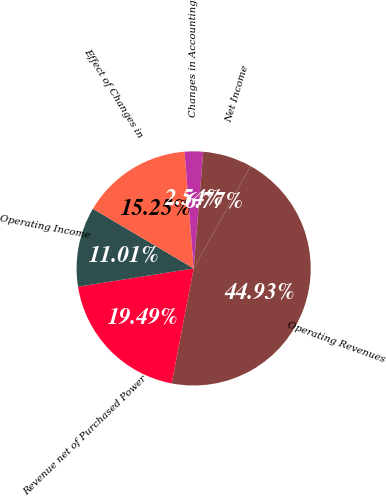Convert chart. <chart><loc_0><loc_0><loc_500><loc_500><pie_chart><fcel>Operating Revenues<fcel>Revenue net of Purchased Power<fcel>Operating Income<fcel>Effect of Changes in<fcel>Changes in Accounting<fcel>Net Income<nl><fcel>44.93%<fcel>19.49%<fcel>11.01%<fcel>15.25%<fcel>2.54%<fcel>6.77%<nl></chart> 